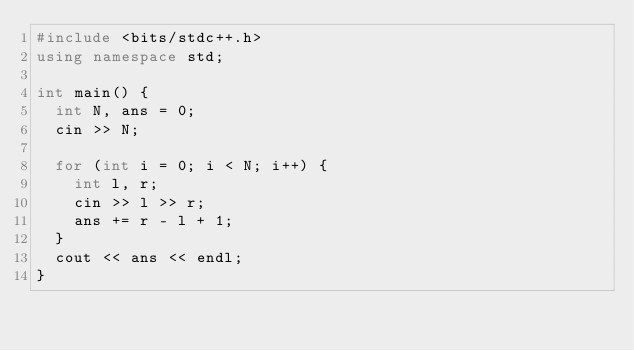Convert code to text. <code><loc_0><loc_0><loc_500><loc_500><_C++_>#include <bits/stdc++.h>
using namespace std;

int main() {
  int N, ans = 0;
  cin >> N;
  
  for (int i = 0; i < N; i++) {
    int l, r;
    cin >> l >> r;
    ans += r - l + 1;
  }
  cout << ans << endl;
}
</code> 